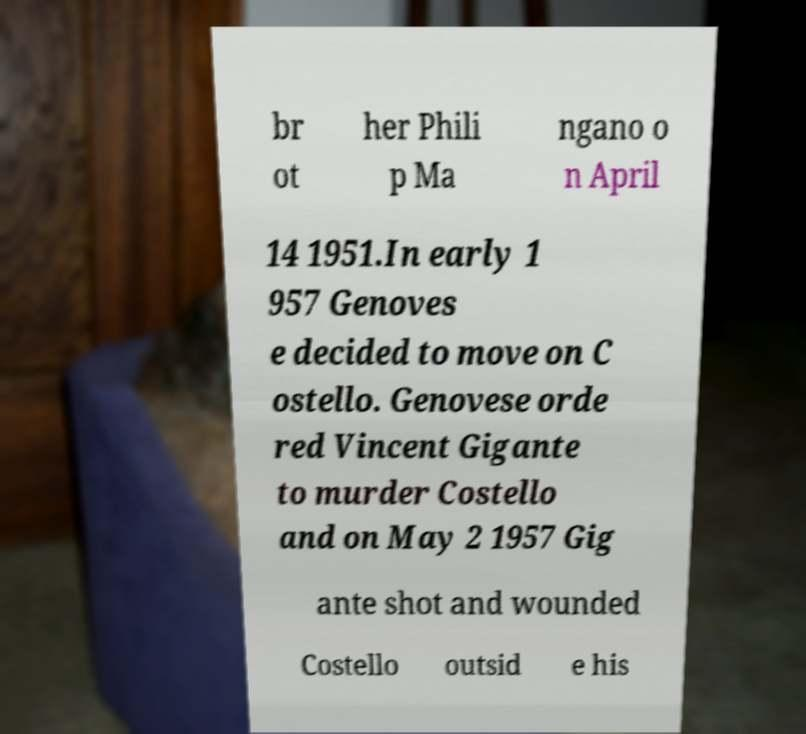Please identify and transcribe the text found in this image. br ot her Phili p Ma ngano o n April 14 1951.In early 1 957 Genoves e decided to move on C ostello. Genovese orde red Vincent Gigante to murder Costello and on May 2 1957 Gig ante shot and wounded Costello outsid e his 